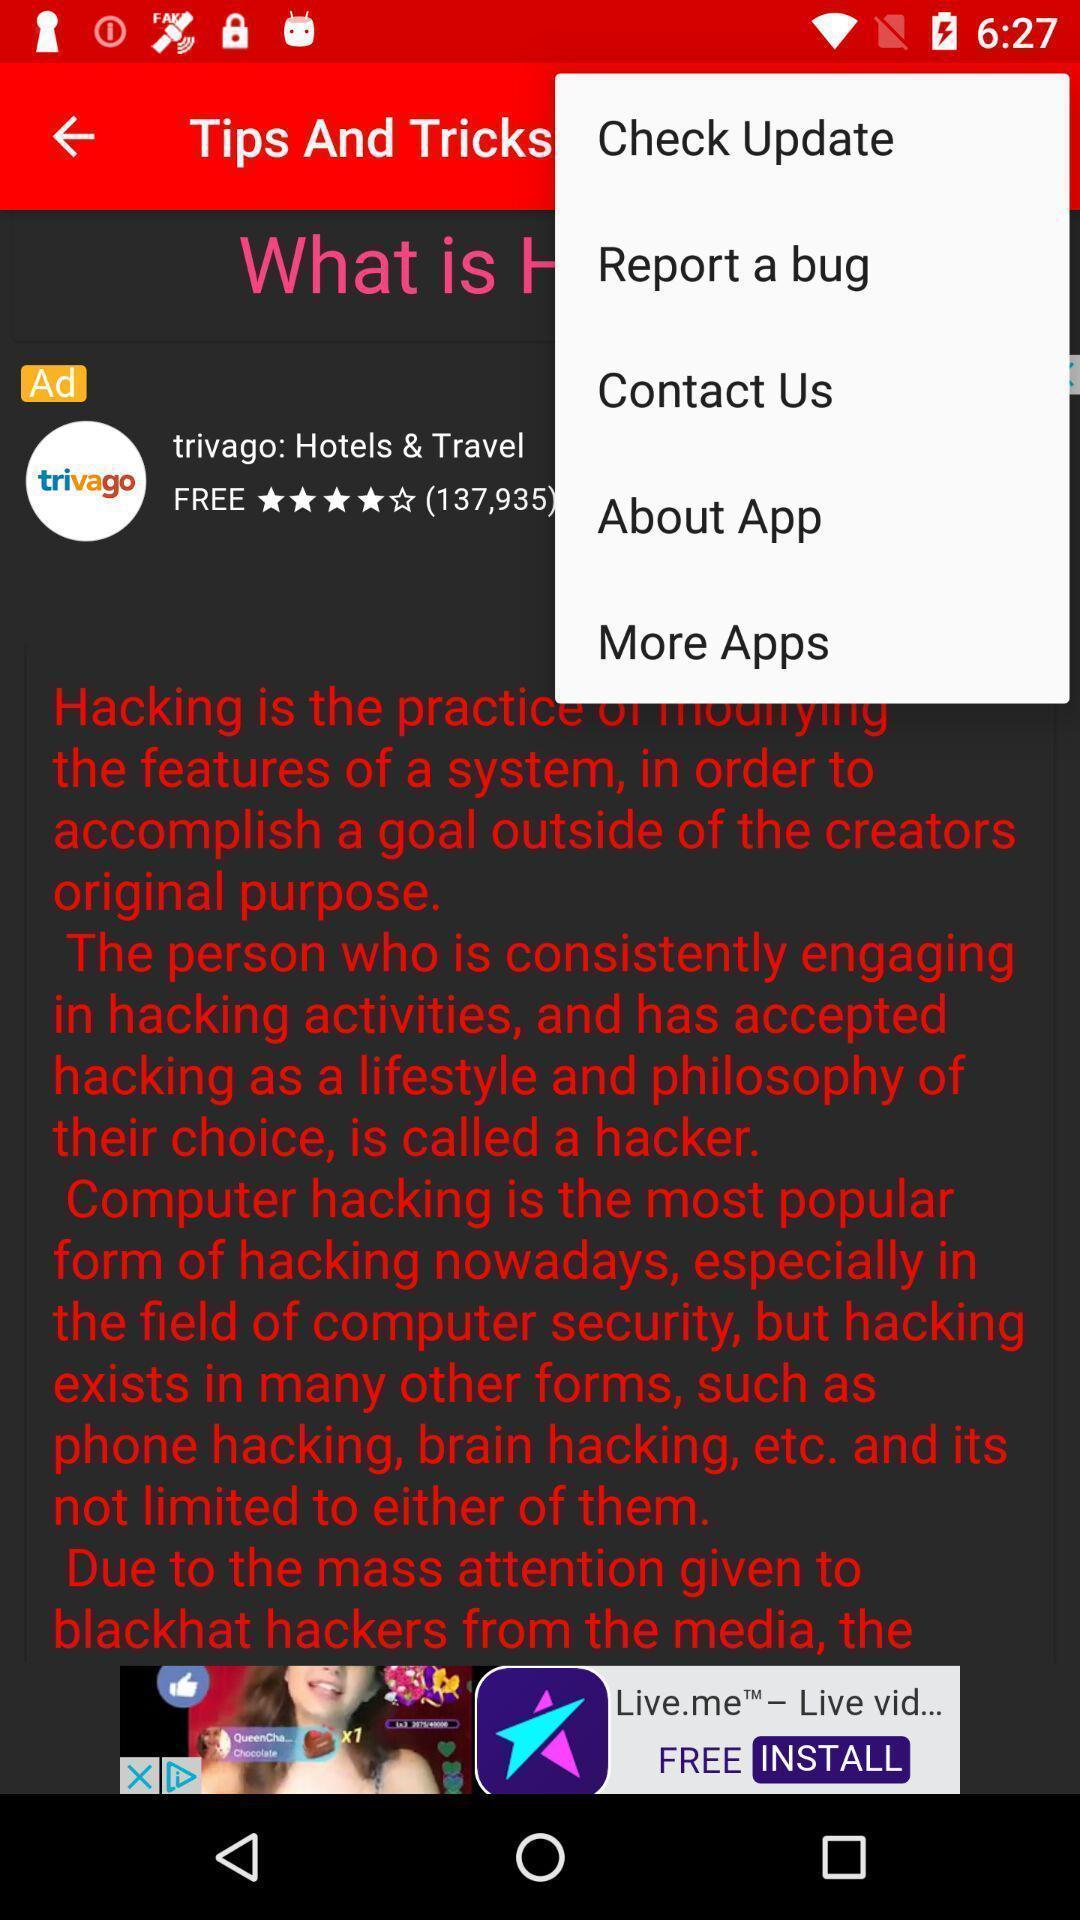Tell me about the visual elements in this screen capture. Screen shows tips tricks. 